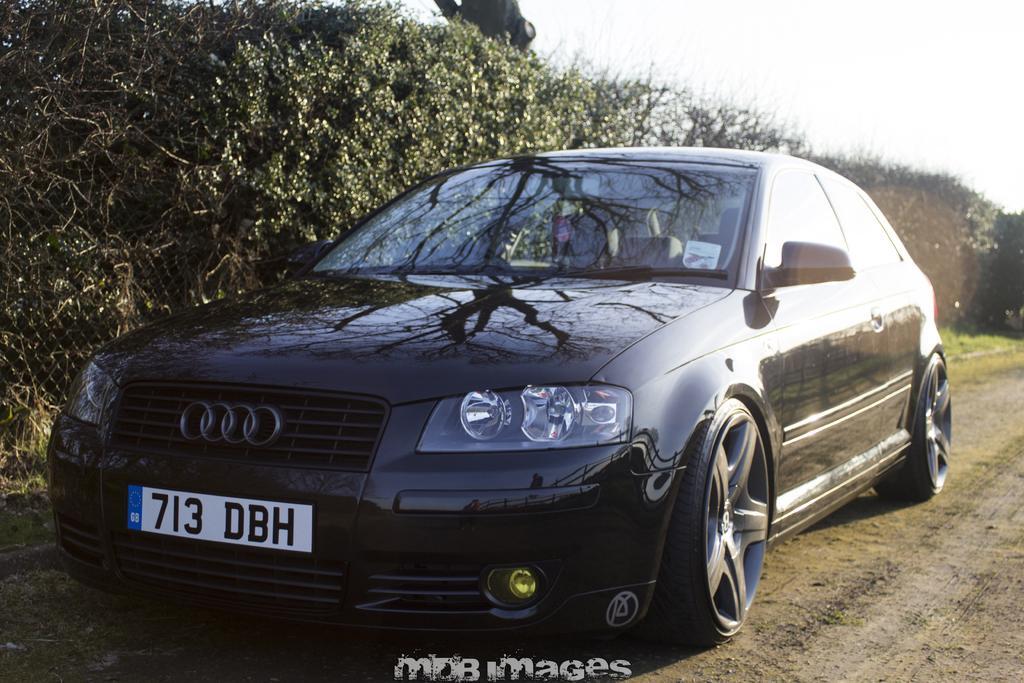How would you summarize this image in a sentence or two? In this picture there is a car which is in black color is on a sand road and there is a fence and few trees in the left corner. 